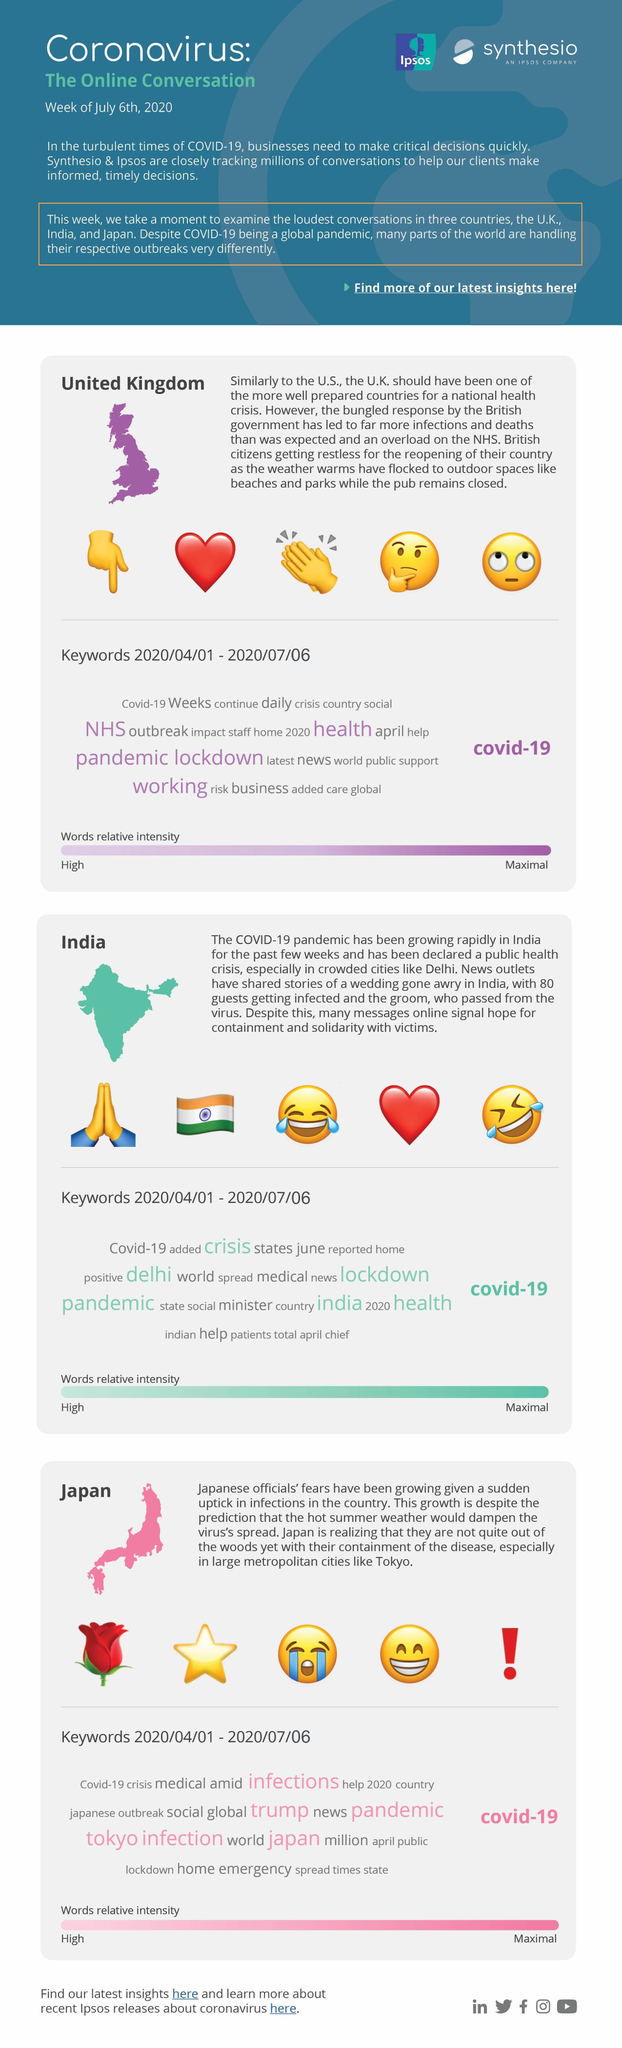Which of these keywords were talked about more in Japan - outbreak, lockdown or infections?
Answer the question with a short phrase. infections Which of these keywords were talked about more in UK - outbreak, pandemic or crisis? pandemic Which keyword was discussed more in India - lockdown, medical or positive? lockdown 